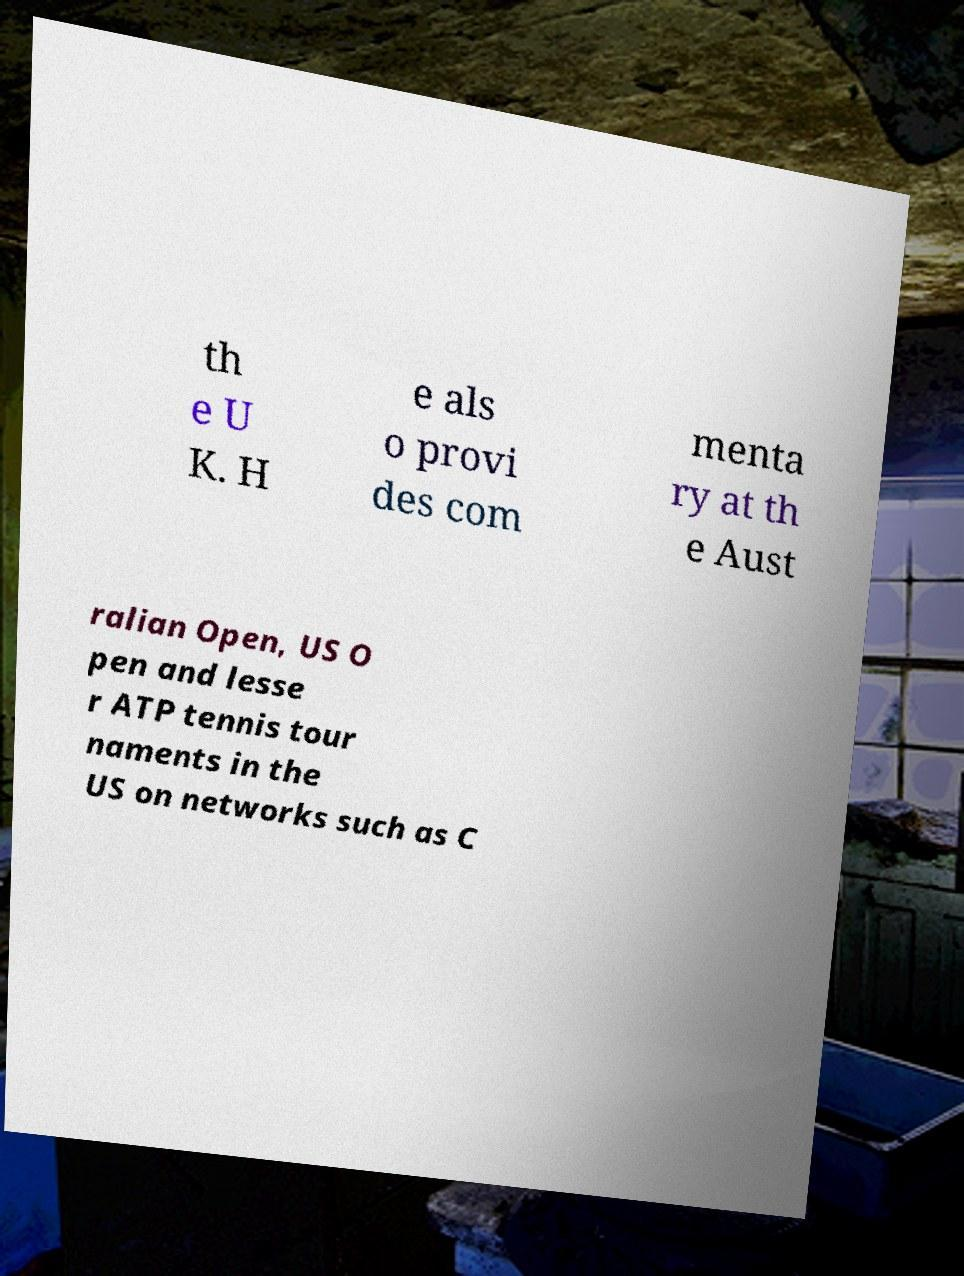Please read and relay the text visible in this image. What does it say? th e U K. H e als o provi des com menta ry at th e Aust ralian Open, US O pen and lesse r ATP tennis tour naments in the US on networks such as C 